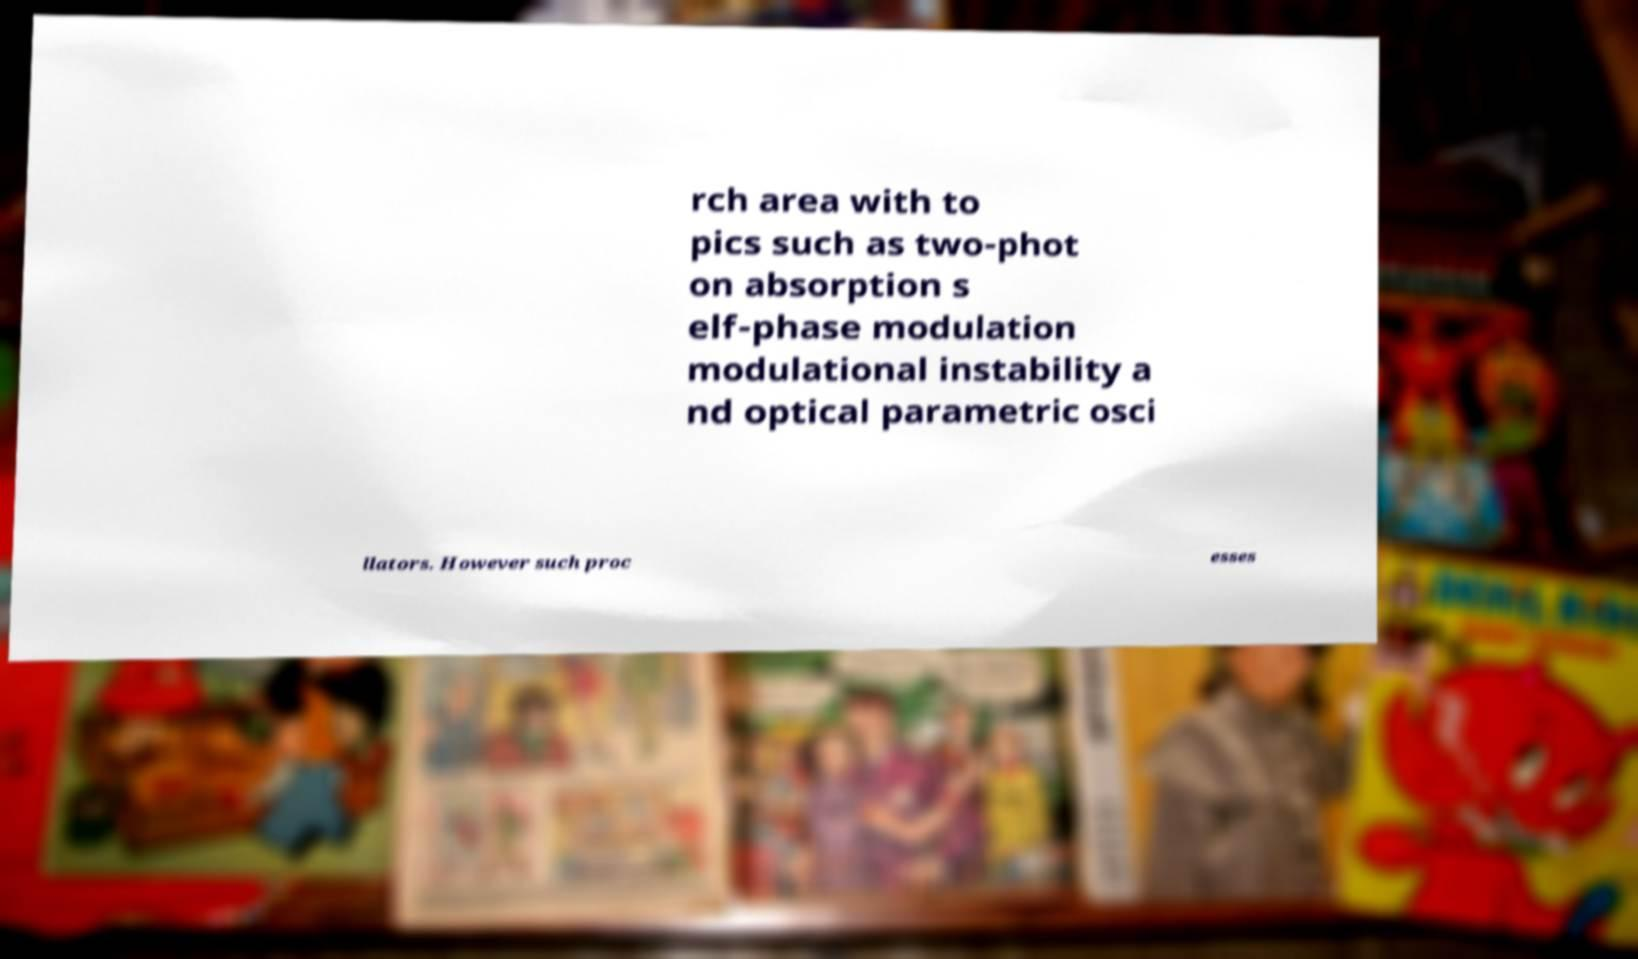Could you assist in decoding the text presented in this image and type it out clearly? rch area with to pics such as two-phot on absorption s elf-phase modulation modulational instability a nd optical parametric osci llators. However such proc esses 